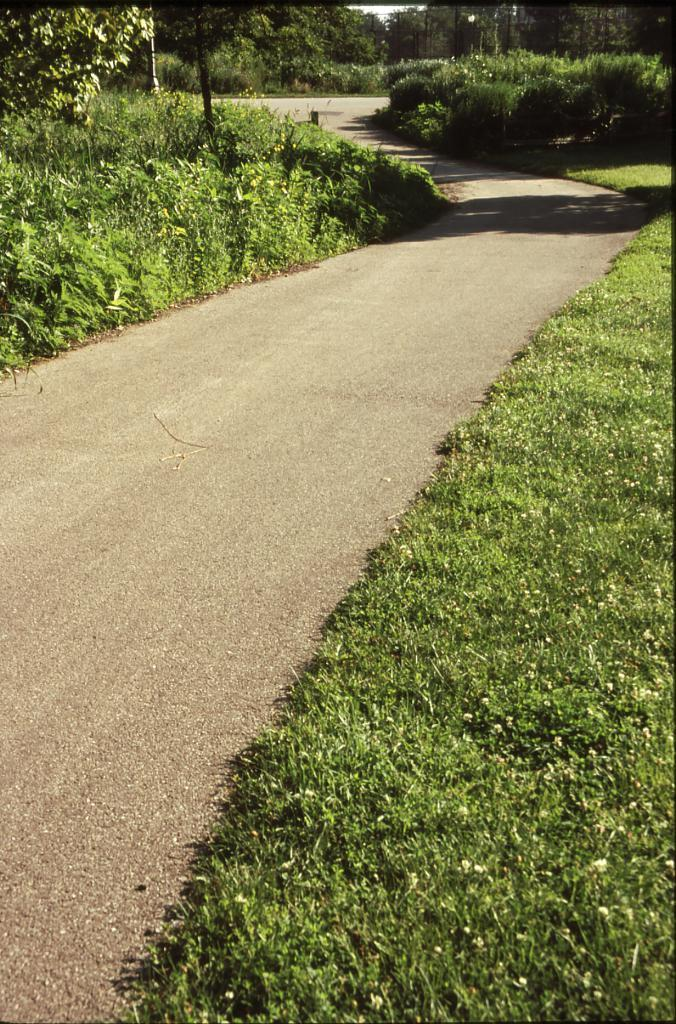Where was the image taken? The image was taken on a road. What can be seen on the ground on either side of the road? There is grass on the ground on either side of the road. What is visible in the background of the image? There are trees and plants in the background. What structures can be seen in the image? There are poles visible in the image. What type of committee is meeting near the trees in the image? There is no committee meeting near the trees in the image; it only shows a road, grass, trees, plants, and poles. Can you see any clams crawling on the grass in the image? There are no clams visible in the image; it only shows a road, grass, trees, plants, and poles. 